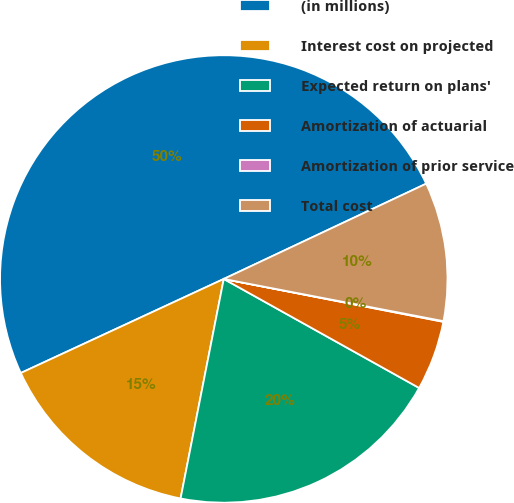Convert chart to OTSL. <chart><loc_0><loc_0><loc_500><loc_500><pie_chart><fcel>(in millions)<fcel>Interest cost on projected<fcel>Expected return on plans'<fcel>Amortization of actuarial<fcel>Amortization of prior service<fcel>Total cost<nl><fcel>49.9%<fcel>15.0%<fcel>19.99%<fcel>5.03%<fcel>0.05%<fcel>10.02%<nl></chart> 